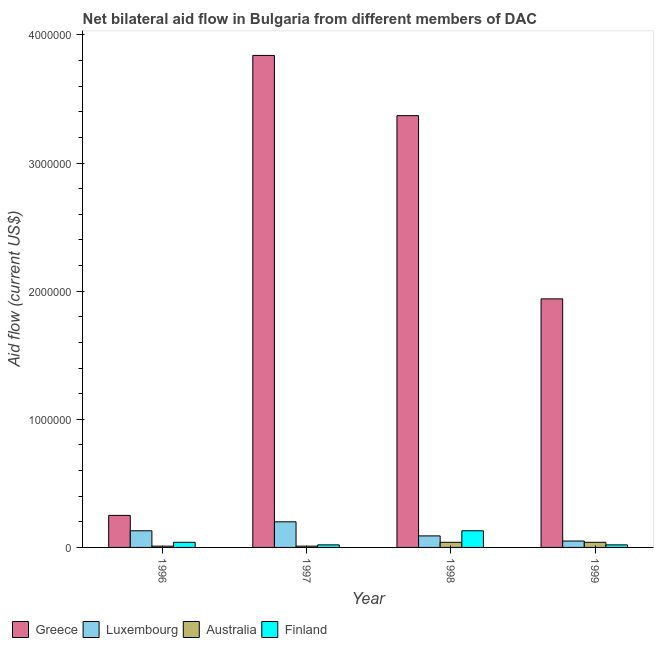How many different coloured bars are there?
Provide a short and direct response. 4. Are the number of bars on each tick of the X-axis equal?
Ensure brevity in your answer.  Yes. How many bars are there on the 4th tick from the right?
Your response must be concise. 4. What is the amount of aid given by australia in 1999?
Make the answer very short. 4.00e+04. Across all years, what is the maximum amount of aid given by greece?
Offer a terse response. 3.84e+06. Across all years, what is the minimum amount of aid given by australia?
Give a very brief answer. 10000. In which year was the amount of aid given by luxembourg maximum?
Keep it short and to the point. 1997. In which year was the amount of aid given by australia minimum?
Give a very brief answer. 1996. What is the total amount of aid given by luxembourg in the graph?
Offer a terse response. 4.70e+05. What is the difference between the amount of aid given by greece in 1996 and that in 1998?
Keep it short and to the point. -3.12e+06. What is the difference between the amount of aid given by greece in 1997 and the amount of aid given by luxembourg in 1996?
Your response must be concise. 3.59e+06. What is the average amount of aid given by finland per year?
Give a very brief answer. 5.25e+04. In how many years, is the amount of aid given by australia greater than 3000000 US$?
Your answer should be compact. 0. What is the ratio of the amount of aid given by finland in 1997 to that in 1999?
Make the answer very short. 1. Is the amount of aid given by greece in 1996 less than that in 1997?
Your answer should be very brief. Yes. What is the difference between the highest and the second highest amount of aid given by greece?
Ensure brevity in your answer.  4.70e+05. What is the difference between the highest and the lowest amount of aid given by luxembourg?
Keep it short and to the point. 1.50e+05. In how many years, is the amount of aid given by australia greater than the average amount of aid given by australia taken over all years?
Offer a very short reply. 2. Is the sum of the amount of aid given by finland in 1996 and 1997 greater than the maximum amount of aid given by australia across all years?
Give a very brief answer. No. Is it the case that in every year, the sum of the amount of aid given by luxembourg and amount of aid given by finland is greater than the sum of amount of aid given by australia and amount of aid given by greece?
Offer a terse response. Yes. What does the 2nd bar from the left in 1997 represents?
Your answer should be compact. Luxembourg. What does the 4th bar from the right in 1999 represents?
Your response must be concise. Greece. How many bars are there?
Offer a very short reply. 16. Does the graph contain any zero values?
Keep it short and to the point. No. Does the graph contain grids?
Make the answer very short. No. Where does the legend appear in the graph?
Your response must be concise. Bottom left. How many legend labels are there?
Give a very brief answer. 4. How are the legend labels stacked?
Your answer should be very brief. Horizontal. What is the title of the graph?
Ensure brevity in your answer.  Net bilateral aid flow in Bulgaria from different members of DAC. Does "Burnt food" appear as one of the legend labels in the graph?
Keep it short and to the point. No. What is the label or title of the Y-axis?
Give a very brief answer. Aid flow (current US$). What is the Aid flow (current US$) of Greece in 1996?
Make the answer very short. 2.50e+05. What is the Aid flow (current US$) in Australia in 1996?
Provide a short and direct response. 10000. What is the Aid flow (current US$) of Greece in 1997?
Offer a terse response. 3.84e+06. What is the Aid flow (current US$) of Luxembourg in 1997?
Provide a succinct answer. 2.00e+05. What is the Aid flow (current US$) in Australia in 1997?
Your answer should be very brief. 10000. What is the Aid flow (current US$) in Greece in 1998?
Give a very brief answer. 3.37e+06. What is the Aid flow (current US$) of Australia in 1998?
Keep it short and to the point. 4.00e+04. What is the Aid flow (current US$) in Finland in 1998?
Offer a very short reply. 1.30e+05. What is the Aid flow (current US$) in Greece in 1999?
Offer a terse response. 1.94e+06. What is the Aid flow (current US$) of Finland in 1999?
Your answer should be compact. 2.00e+04. Across all years, what is the maximum Aid flow (current US$) in Greece?
Your answer should be compact. 3.84e+06. Across all years, what is the maximum Aid flow (current US$) in Luxembourg?
Give a very brief answer. 2.00e+05. Across all years, what is the minimum Aid flow (current US$) of Greece?
Ensure brevity in your answer.  2.50e+05. Across all years, what is the minimum Aid flow (current US$) of Australia?
Offer a very short reply. 10000. Across all years, what is the minimum Aid flow (current US$) of Finland?
Make the answer very short. 2.00e+04. What is the total Aid flow (current US$) of Greece in the graph?
Provide a succinct answer. 9.40e+06. What is the total Aid flow (current US$) in Luxembourg in the graph?
Keep it short and to the point. 4.70e+05. What is the total Aid flow (current US$) in Australia in the graph?
Offer a terse response. 1.00e+05. What is the total Aid flow (current US$) in Finland in the graph?
Offer a very short reply. 2.10e+05. What is the difference between the Aid flow (current US$) in Greece in 1996 and that in 1997?
Provide a succinct answer. -3.59e+06. What is the difference between the Aid flow (current US$) of Luxembourg in 1996 and that in 1997?
Provide a succinct answer. -7.00e+04. What is the difference between the Aid flow (current US$) of Australia in 1996 and that in 1997?
Your answer should be very brief. 0. What is the difference between the Aid flow (current US$) of Greece in 1996 and that in 1998?
Your response must be concise. -3.12e+06. What is the difference between the Aid flow (current US$) in Luxembourg in 1996 and that in 1998?
Your answer should be compact. 4.00e+04. What is the difference between the Aid flow (current US$) in Australia in 1996 and that in 1998?
Make the answer very short. -3.00e+04. What is the difference between the Aid flow (current US$) in Greece in 1996 and that in 1999?
Keep it short and to the point. -1.69e+06. What is the difference between the Aid flow (current US$) of Luxembourg in 1996 and that in 1999?
Your answer should be very brief. 8.00e+04. What is the difference between the Aid flow (current US$) of Finland in 1996 and that in 1999?
Offer a very short reply. 2.00e+04. What is the difference between the Aid flow (current US$) in Greece in 1997 and that in 1998?
Offer a very short reply. 4.70e+05. What is the difference between the Aid flow (current US$) in Greece in 1997 and that in 1999?
Keep it short and to the point. 1.90e+06. What is the difference between the Aid flow (current US$) of Australia in 1997 and that in 1999?
Your answer should be compact. -3.00e+04. What is the difference between the Aid flow (current US$) of Greece in 1998 and that in 1999?
Offer a terse response. 1.43e+06. What is the difference between the Aid flow (current US$) in Greece in 1996 and the Aid flow (current US$) in Australia in 1997?
Your answer should be very brief. 2.40e+05. What is the difference between the Aid flow (current US$) of Australia in 1996 and the Aid flow (current US$) of Finland in 1997?
Your answer should be compact. -10000. What is the difference between the Aid flow (current US$) of Greece in 1996 and the Aid flow (current US$) of Finland in 1998?
Your answer should be very brief. 1.20e+05. What is the difference between the Aid flow (current US$) of Luxembourg in 1996 and the Aid flow (current US$) of Australia in 1998?
Provide a succinct answer. 9.00e+04. What is the difference between the Aid flow (current US$) of Luxembourg in 1996 and the Aid flow (current US$) of Finland in 1998?
Give a very brief answer. 0. What is the difference between the Aid flow (current US$) in Australia in 1996 and the Aid flow (current US$) in Finland in 1999?
Your response must be concise. -10000. What is the difference between the Aid flow (current US$) of Greece in 1997 and the Aid flow (current US$) of Luxembourg in 1998?
Your answer should be compact. 3.75e+06. What is the difference between the Aid flow (current US$) in Greece in 1997 and the Aid flow (current US$) in Australia in 1998?
Your answer should be compact. 3.80e+06. What is the difference between the Aid flow (current US$) in Greece in 1997 and the Aid flow (current US$) in Finland in 1998?
Offer a terse response. 3.71e+06. What is the difference between the Aid flow (current US$) of Luxembourg in 1997 and the Aid flow (current US$) of Australia in 1998?
Ensure brevity in your answer.  1.60e+05. What is the difference between the Aid flow (current US$) of Greece in 1997 and the Aid flow (current US$) of Luxembourg in 1999?
Make the answer very short. 3.79e+06. What is the difference between the Aid flow (current US$) of Greece in 1997 and the Aid flow (current US$) of Australia in 1999?
Your response must be concise. 3.80e+06. What is the difference between the Aid flow (current US$) in Greece in 1997 and the Aid flow (current US$) in Finland in 1999?
Ensure brevity in your answer.  3.82e+06. What is the difference between the Aid flow (current US$) in Luxembourg in 1997 and the Aid flow (current US$) in Australia in 1999?
Provide a succinct answer. 1.60e+05. What is the difference between the Aid flow (current US$) of Luxembourg in 1997 and the Aid flow (current US$) of Finland in 1999?
Give a very brief answer. 1.80e+05. What is the difference between the Aid flow (current US$) of Greece in 1998 and the Aid flow (current US$) of Luxembourg in 1999?
Your response must be concise. 3.32e+06. What is the difference between the Aid flow (current US$) of Greece in 1998 and the Aid flow (current US$) of Australia in 1999?
Make the answer very short. 3.33e+06. What is the difference between the Aid flow (current US$) of Greece in 1998 and the Aid flow (current US$) of Finland in 1999?
Offer a very short reply. 3.35e+06. What is the difference between the Aid flow (current US$) in Luxembourg in 1998 and the Aid flow (current US$) in Australia in 1999?
Your answer should be very brief. 5.00e+04. What is the difference between the Aid flow (current US$) in Australia in 1998 and the Aid flow (current US$) in Finland in 1999?
Offer a very short reply. 2.00e+04. What is the average Aid flow (current US$) in Greece per year?
Give a very brief answer. 2.35e+06. What is the average Aid flow (current US$) of Luxembourg per year?
Make the answer very short. 1.18e+05. What is the average Aid flow (current US$) of Australia per year?
Your response must be concise. 2.50e+04. What is the average Aid flow (current US$) in Finland per year?
Ensure brevity in your answer.  5.25e+04. In the year 1996, what is the difference between the Aid flow (current US$) in Greece and Aid flow (current US$) in Finland?
Make the answer very short. 2.10e+05. In the year 1996, what is the difference between the Aid flow (current US$) in Luxembourg and Aid flow (current US$) in Australia?
Give a very brief answer. 1.20e+05. In the year 1996, what is the difference between the Aid flow (current US$) in Luxembourg and Aid flow (current US$) in Finland?
Your answer should be compact. 9.00e+04. In the year 1996, what is the difference between the Aid flow (current US$) of Australia and Aid flow (current US$) of Finland?
Ensure brevity in your answer.  -3.00e+04. In the year 1997, what is the difference between the Aid flow (current US$) of Greece and Aid flow (current US$) of Luxembourg?
Ensure brevity in your answer.  3.64e+06. In the year 1997, what is the difference between the Aid flow (current US$) in Greece and Aid flow (current US$) in Australia?
Offer a terse response. 3.83e+06. In the year 1997, what is the difference between the Aid flow (current US$) of Greece and Aid flow (current US$) of Finland?
Offer a very short reply. 3.82e+06. In the year 1997, what is the difference between the Aid flow (current US$) of Luxembourg and Aid flow (current US$) of Australia?
Provide a succinct answer. 1.90e+05. In the year 1997, what is the difference between the Aid flow (current US$) in Luxembourg and Aid flow (current US$) in Finland?
Your answer should be compact. 1.80e+05. In the year 1997, what is the difference between the Aid flow (current US$) of Australia and Aid flow (current US$) of Finland?
Your answer should be very brief. -10000. In the year 1998, what is the difference between the Aid flow (current US$) of Greece and Aid flow (current US$) of Luxembourg?
Give a very brief answer. 3.28e+06. In the year 1998, what is the difference between the Aid flow (current US$) in Greece and Aid flow (current US$) in Australia?
Offer a terse response. 3.33e+06. In the year 1998, what is the difference between the Aid flow (current US$) in Greece and Aid flow (current US$) in Finland?
Provide a succinct answer. 3.24e+06. In the year 1998, what is the difference between the Aid flow (current US$) of Luxembourg and Aid flow (current US$) of Finland?
Give a very brief answer. -4.00e+04. In the year 1999, what is the difference between the Aid flow (current US$) of Greece and Aid flow (current US$) of Luxembourg?
Provide a short and direct response. 1.89e+06. In the year 1999, what is the difference between the Aid flow (current US$) in Greece and Aid flow (current US$) in Australia?
Offer a very short reply. 1.90e+06. In the year 1999, what is the difference between the Aid flow (current US$) in Greece and Aid flow (current US$) in Finland?
Provide a short and direct response. 1.92e+06. In the year 1999, what is the difference between the Aid flow (current US$) of Luxembourg and Aid flow (current US$) of Australia?
Offer a very short reply. 10000. In the year 1999, what is the difference between the Aid flow (current US$) in Luxembourg and Aid flow (current US$) in Finland?
Keep it short and to the point. 3.00e+04. What is the ratio of the Aid flow (current US$) of Greece in 1996 to that in 1997?
Provide a succinct answer. 0.07. What is the ratio of the Aid flow (current US$) of Luxembourg in 1996 to that in 1997?
Provide a succinct answer. 0.65. What is the ratio of the Aid flow (current US$) of Australia in 1996 to that in 1997?
Give a very brief answer. 1. What is the ratio of the Aid flow (current US$) in Finland in 1996 to that in 1997?
Keep it short and to the point. 2. What is the ratio of the Aid flow (current US$) of Greece in 1996 to that in 1998?
Offer a terse response. 0.07. What is the ratio of the Aid flow (current US$) in Luxembourg in 1996 to that in 1998?
Provide a succinct answer. 1.44. What is the ratio of the Aid flow (current US$) of Finland in 1996 to that in 1998?
Keep it short and to the point. 0.31. What is the ratio of the Aid flow (current US$) in Greece in 1996 to that in 1999?
Your answer should be very brief. 0.13. What is the ratio of the Aid flow (current US$) in Luxembourg in 1996 to that in 1999?
Your response must be concise. 2.6. What is the ratio of the Aid flow (current US$) of Finland in 1996 to that in 1999?
Offer a terse response. 2. What is the ratio of the Aid flow (current US$) in Greece in 1997 to that in 1998?
Ensure brevity in your answer.  1.14. What is the ratio of the Aid flow (current US$) in Luxembourg in 1997 to that in 1998?
Keep it short and to the point. 2.22. What is the ratio of the Aid flow (current US$) of Finland in 1997 to that in 1998?
Your response must be concise. 0.15. What is the ratio of the Aid flow (current US$) in Greece in 1997 to that in 1999?
Make the answer very short. 1.98. What is the ratio of the Aid flow (current US$) of Luxembourg in 1997 to that in 1999?
Your answer should be compact. 4. What is the ratio of the Aid flow (current US$) of Greece in 1998 to that in 1999?
Make the answer very short. 1.74. What is the ratio of the Aid flow (current US$) in Luxembourg in 1998 to that in 1999?
Keep it short and to the point. 1.8. What is the ratio of the Aid flow (current US$) of Australia in 1998 to that in 1999?
Provide a succinct answer. 1. What is the difference between the highest and the second highest Aid flow (current US$) of Greece?
Provide a succinct answer. 4.70e+05. What is the difference between the highest and the lowest Aid flow (current US$) in Greece?
Give a very brief answer. 3.59e+06. What is the difference between the highest and the lowest Aid flow (current US$) in Finland?
Give a very brief answer. 1.10e+05. 